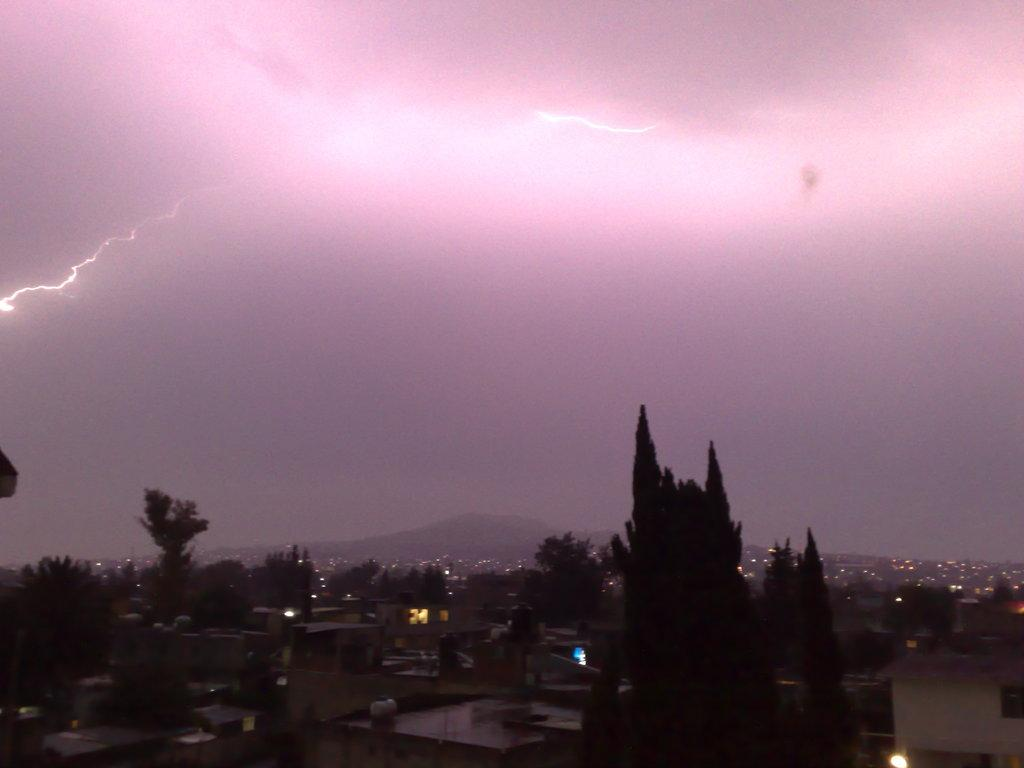What type of structures can be seen at the bottom side of the image? There are buildings in the image. What type of vegetation is also present at the bottom side of the image? There are trees in the image. What is visible at the top side of the image? The sky is visible at the top side of the image. What type of maid can be seen working in the garden of the property in the image? There is no maid or garden present in the image; it only features buildings, trees, and the sky. 